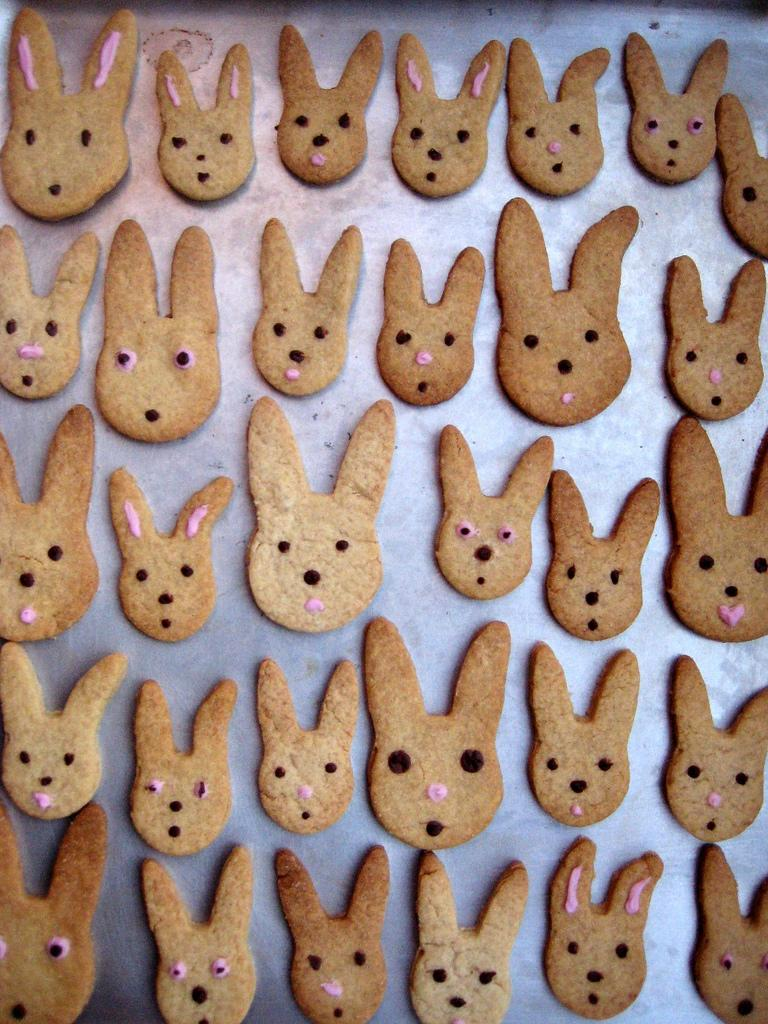What objects are on the tray in the image? There are dough cutters on a tray in the image. What is the reaction of the dough cutters when exposed to sunlight in the image? There is no indication of sunlight or any reaction of the dough cutters in the image. 